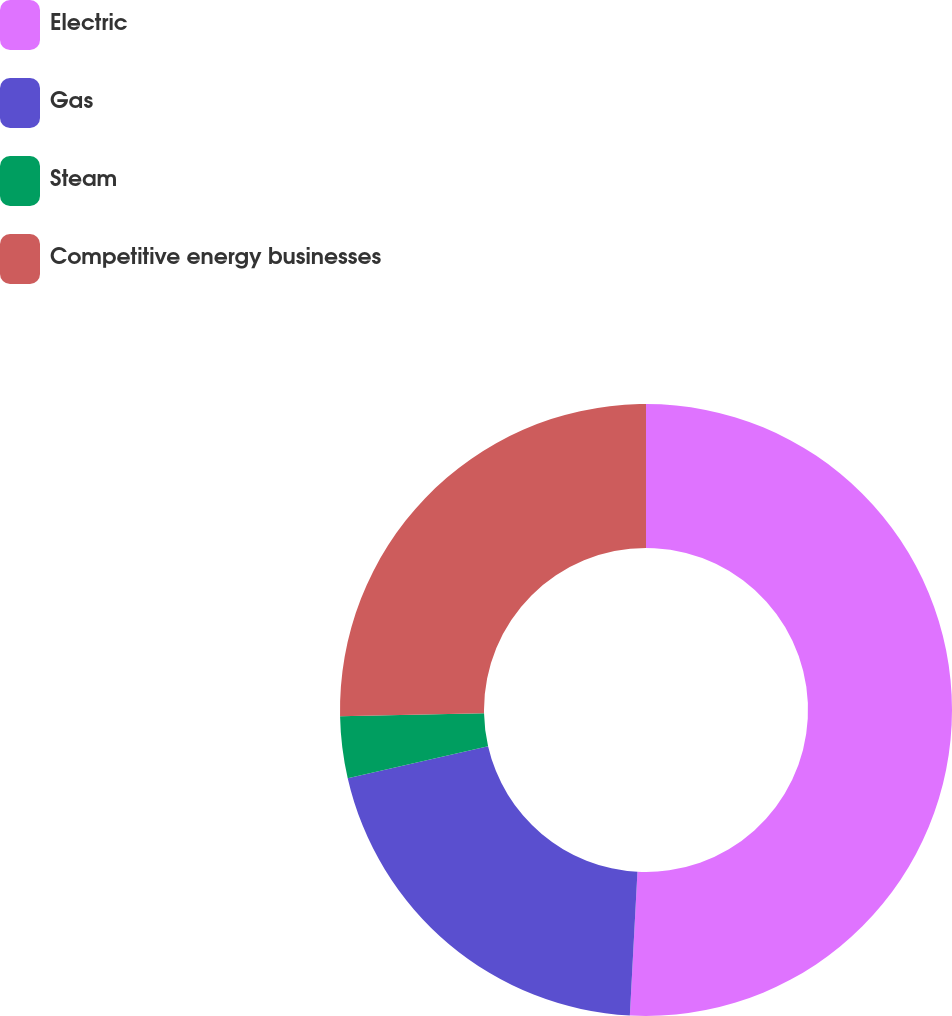Convert chart to OTSL. <chart><loc_0><loc_0><loc_500><loc_500><pie_chart><fcel>Electric<fcel>Gas<fcel>Steam<fcel>Competitive energy businesses<nl><fcel>50.84%<fcel>20.58%<fcel>3.25%<fcel>25.33%<nl></chart> 